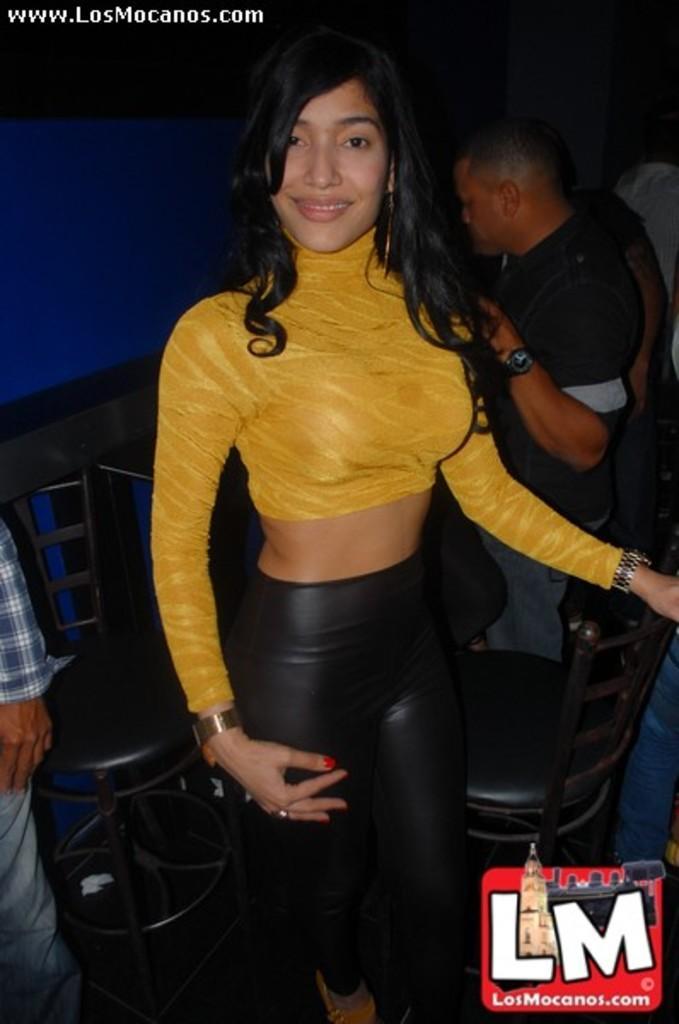How would you summarize this image in a sentence or two? In this image we can see a lady is standing and she wore a yellow color dress and a watch. On the right bottom side of the image we can see a logo. 